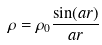Convert formula to latex. <formula><loc_0><loc_0><loc_500><loc_500>\rho = \rho _ { 0 } \frac { \sin ( a r ) } { a r }</formula> 